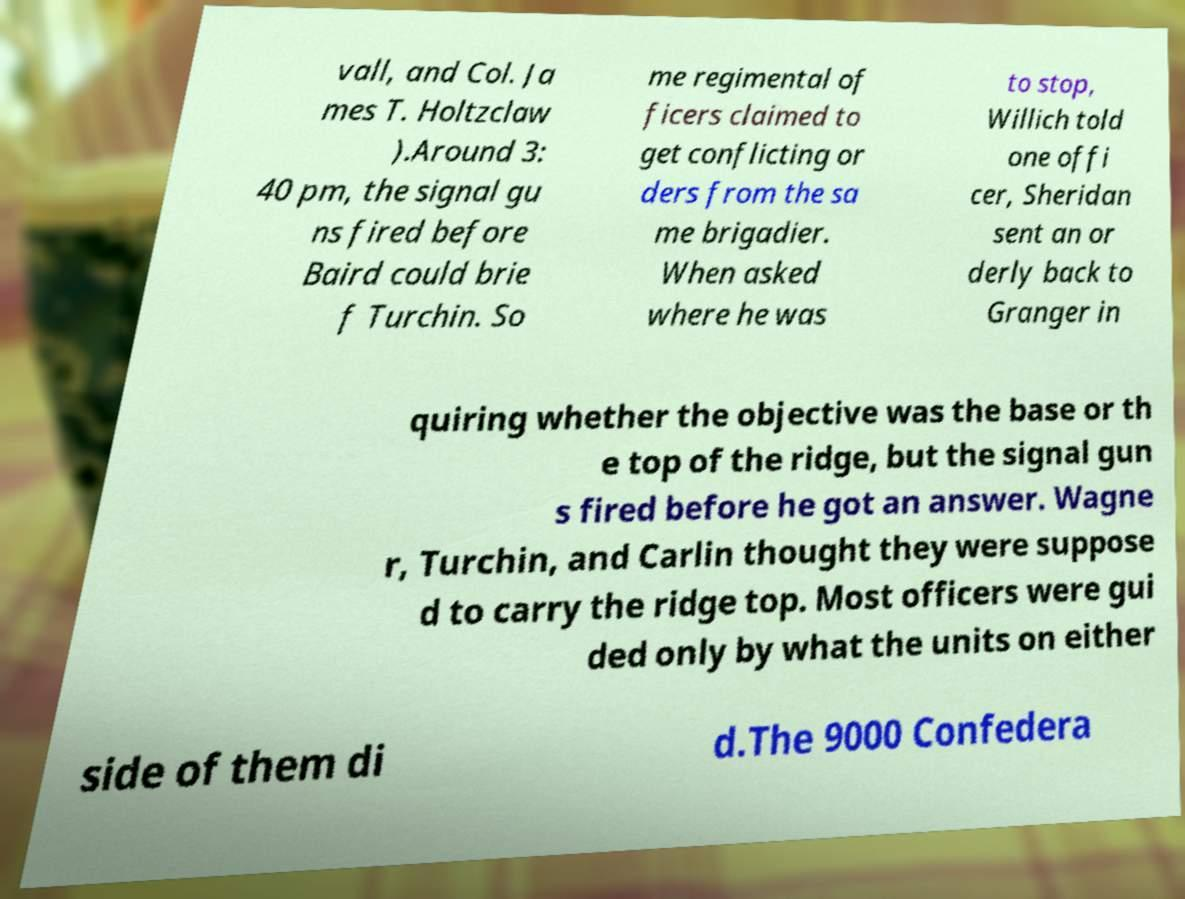Could you extract and type out the text from this image? vall, and Col. Ja mes T. Holtzclaw ).Around 3: 40 pm, the signal gu ns fired before Baird could brie f Turchin. So me regimental of ficers claimed to get conflicting or ders from the sa me brigadier. When asked where he was to stop, Willich told one offi cer, Sheridan sent an or derly back to Granger in quiring whether the objective was the base or th e top of the ridge, but the signal gun s fired before he got an answer. Wagne r, Turchin, and Carlin thought they were suppose d to carry the ridge top. Most officers were gui ded only by what the units on either side of them di d.The 9000 Confedera 